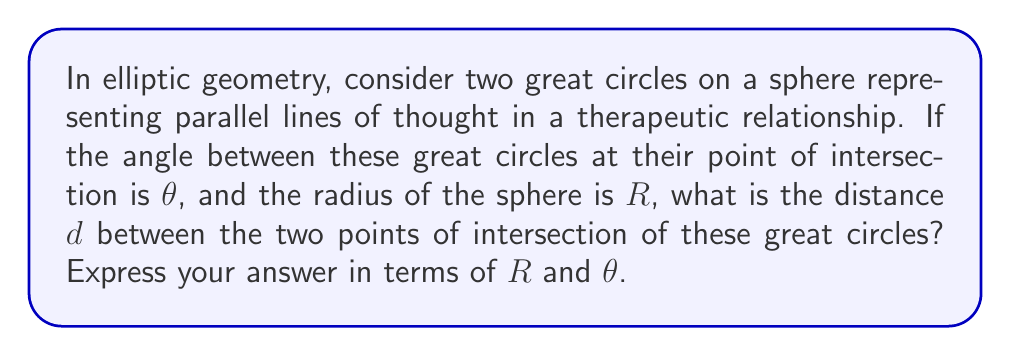Help me with this question. Let's approach this step-by-step:

1) In elliptic geometry, parallel lines are represented by great circles on a sphere that intersect at two antipodal points.

2) The distance between two points on a sphere is measured along the arc of the great circle passing through those points.

3) The angle $\theta$ between the great circles at their intersection point is related to the central angle subtended by the arc connecting the two intersection points.

4) In a sphere, the relationship between the central angle $\alpha$ (in radians) and the arc length $s$ is:

   $$s = R\alpha$$

5) The central angle $\alpha$ is related to the angle $\theta$ between the great circles:

   $$\alpha = \pi - \theta$$

   This is because the sum of angles in a spherical triangle is greater than $\pi$, and the "parallel" great circles form two congruent spherical triangles.

6) Substituting this into the arc length formula:

   $$d = R(\pi - \theta)$$

7) This formula represents how the "distance" between parallel lines of thought in a therapeutic relationship (represented by $d$) can vary based on the "angle" of perspective ($\theta$) within the "sphere" of the therapeutic environment (radius $R$).

[asy]
import geometry;

unitsize(1cm);

pair O=(0,0);
real R=3;
draw(circle(O,R));
real theta=pi/3;
draw(arc(O,R,0,180),blue);
draw(arc(O,R,theta,180+theta),red);
dot("A",R*dir(0));
dot("B",R*dir(180));
dot("C",R*dir(theta));
dot("D",R*dir(180+theta));
label("$\theta$",R*dir(theta/2),NE);
label("$R$",O--A,SE);
draw(O--A);
</asy]
Answer: $d = R(\pi - \theta)$ 